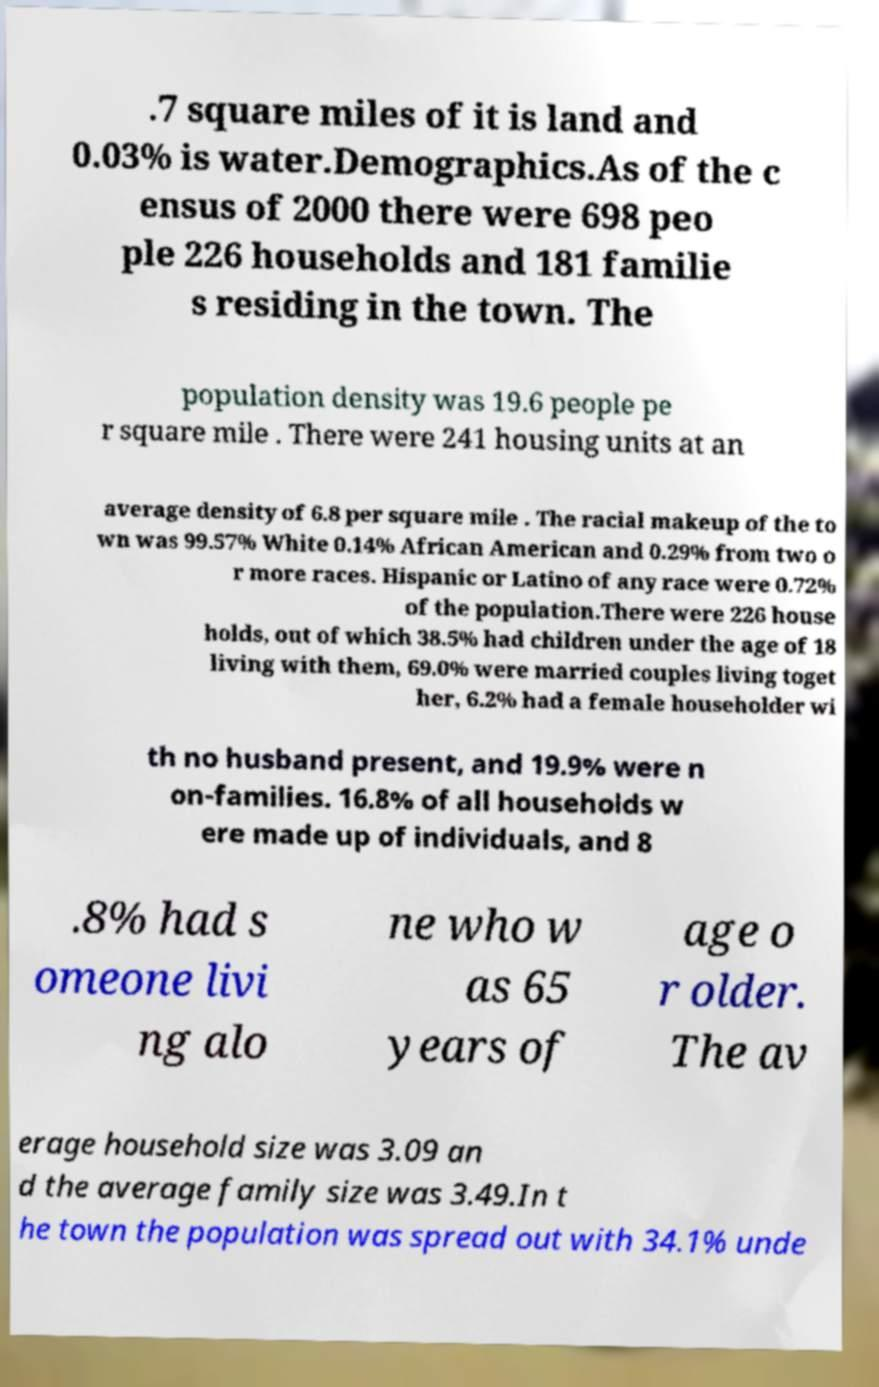Could you extract and type out the text from this image? .7 square miles of it is land and 0.03% is water.Demographics.As of the c ensus of 2000 there were 698 peo ple 226 households and 181 familie s residing in the town. The population density was 19.6 people pe r square mile . There were 241 housing units at an average density of 6.8 per square mile . The racial makeup of the to wn was 99.57% White 0.14% African American and 0.29% from two o r more races. Hispanic or Latino of any race were 0.72% of the population.There were 226 house holds, out of which 38.5% had children under the age of 18 living with them, 69.0% were married couples living toget her, 6.2% had a female householder wi th no husband present, and 19.9% were n on-families. 16.8% of all households w ere made up of individuals, and 8 .8% had s omeone livi ng alo ne who w as 65 years of age o r older. The av erage household size was 3.09 an d the average family size was 3.49.In t he town the population was spread out with 34.1% unde 